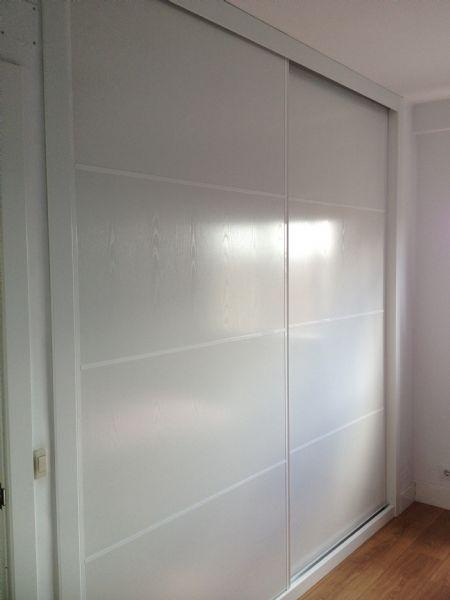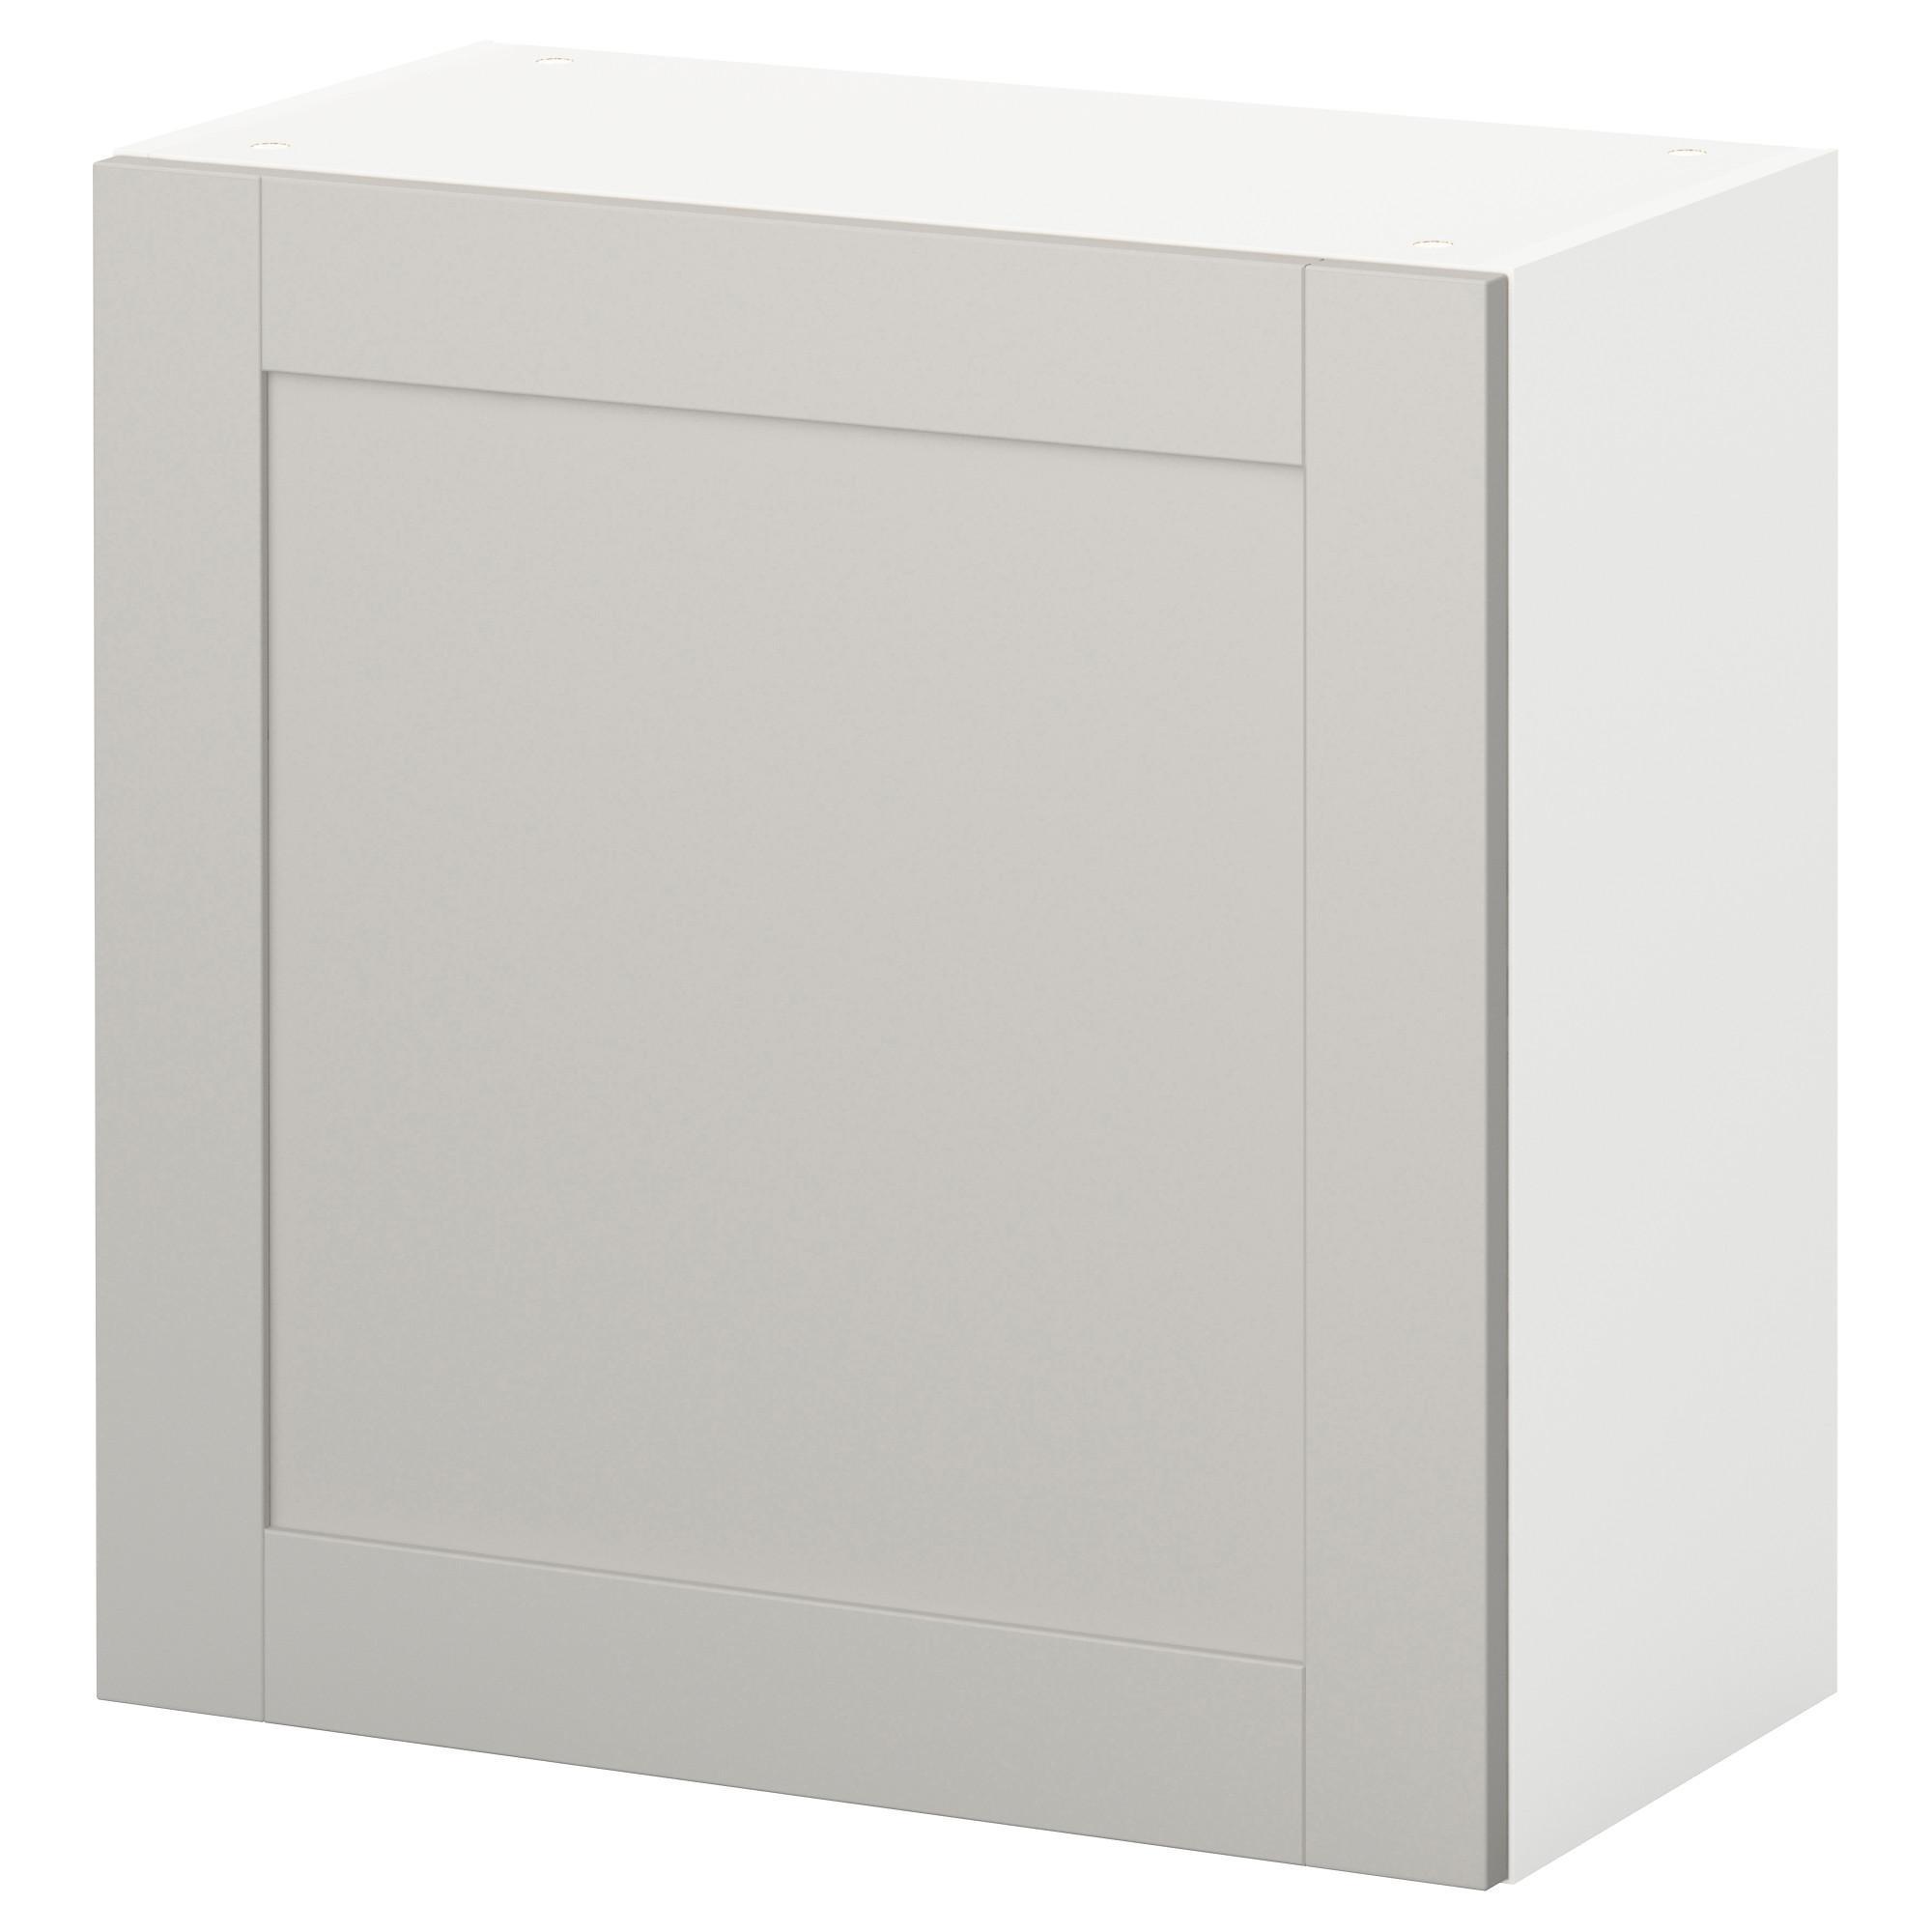The first image is the image on the left, the second image is the image on the right. For the images displayed, is the sentence "The closet in the image on the left is partially open." factually correct? Answer yes or no. No. 